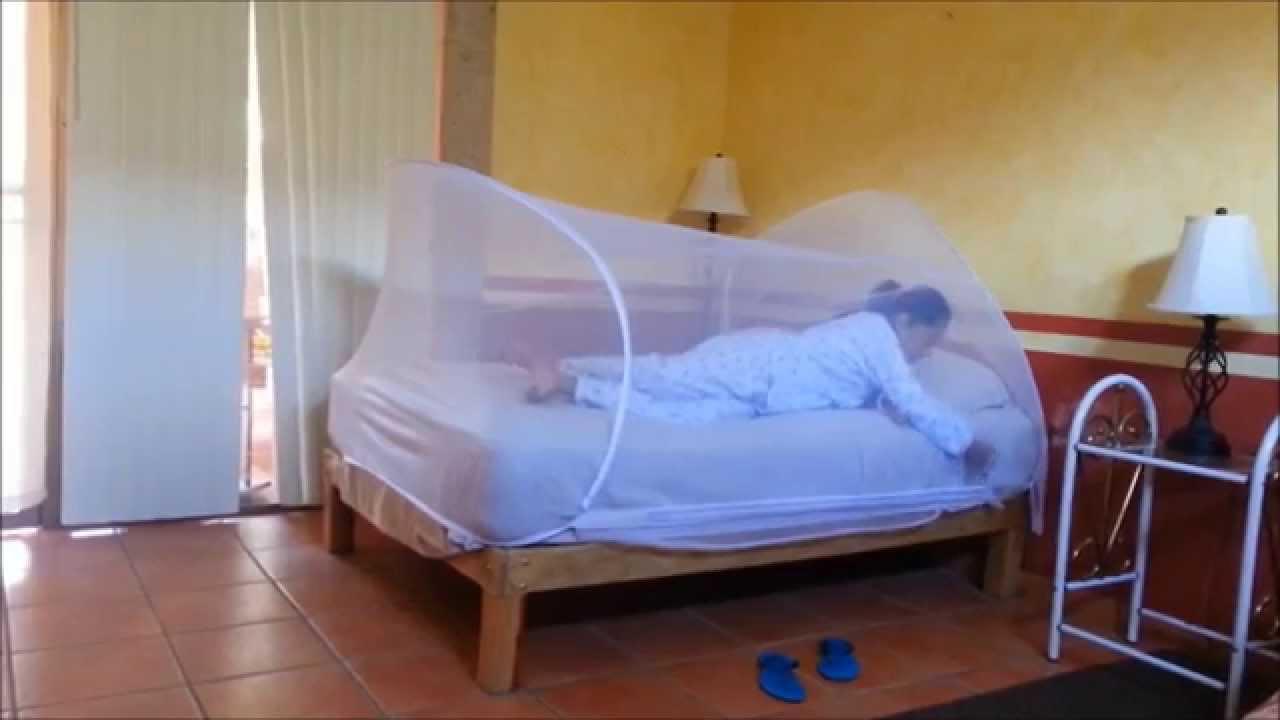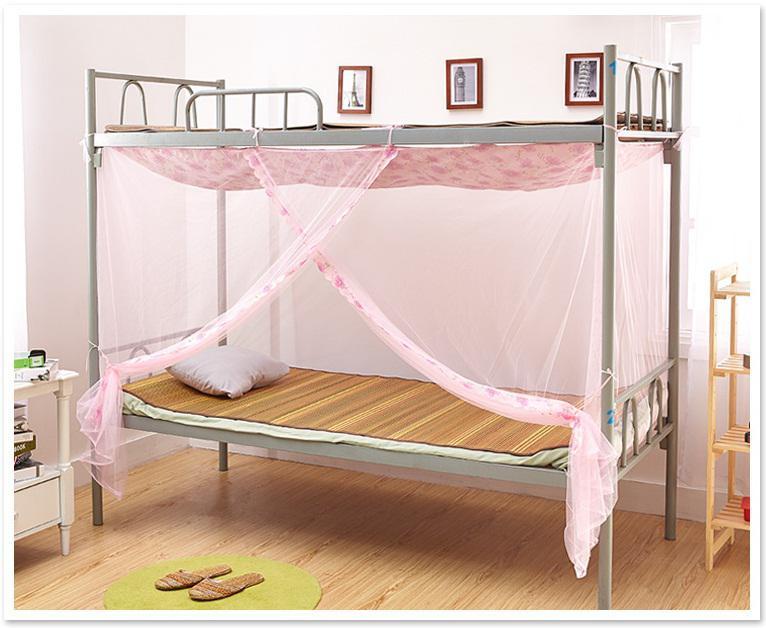The first image is the image on the left, the second image is the image on the right. Given the left and right images, does the statement "At least one image shows a bed with a wooden headboard." hold true? Answer yes or no. No. The first image is the image on the left, the second image is the image on the right. Examine the images to the left and right. Is the description "One of the walls has at least one rectangular picture hanging from it." accurate? Answer yes or no. Yes. 